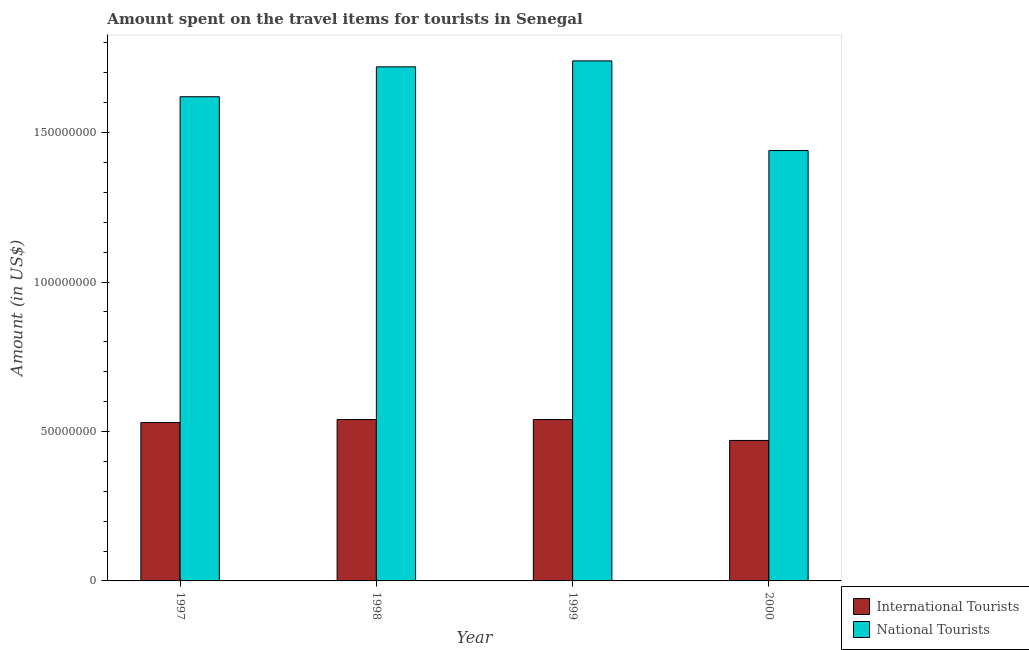How many different coloured bars are there?
Your response must be concise. 2. How many groups of bars are there?
Provide a succinct answer. 4. Are the number of bars per tick equal to the number of legend labels?
Give a very brief answer. Yes. How many bars are there on the 1st tick from the left?
Your answer should be very brief. 2. What is the label of the 4th group of bars from the left?
Your answer should be compact. 2000. What is the amount spent on travel items of national tourists in 1997?
Your response must be concise. 1.62e+08. Across all years, what is the maximum amount spent on travel items of international tourists?
Your response must be concise. 5.40e+07. Across all years, what is the minimum amount spent on travel items of international tourists?
Offer a very short reply. 4.70e+07. What is the total amount spent on travel items of national tourists in the graph?
Keep it short and to the point. 6.52e+08. What is the difference between the amount spent on travel items of international tourists in 1997 and that in 1998?
Ensure brevity in your answer.  -1.00e+06. What is the difference between the amount spent on travel items of national tourists in 2000 and the amount spent on travel items of international tourists in 1997?
Provide a short and direct response. -1.80e+07. What is the average amount spent on travel items of international tourists per year?
Ensure brevity in your answer.  5.20e+07. In the year 1999, what is the difference between the amount spent on travel items of international tourists and amount spent on travel items of national tourists?
Your response must be concise. 0. In how many years, is the amount spent on travel items of national tourists greater than 140000000 US$?
Your response must be concise. 4. What is the ratio of the amount spent on travel items of international tourists in 1997 to that in 1999?
Offer a terse response. 0.98. Is the amount spent on travel items of national tourists in 1998 less than that in 2000?
Ensure brevity in your answer.  No. Is the difference between the amount spent on travel items of international tourists in 1998 and 1999 greater than the difference between the amount spent on travel items of national tourists in 1998 and 1999?
Your answer should be compact. No. What is the difference between the highest and the second highest amount spent on travel items of national tourists?
Give a very brief answer. 2.00e+06. What is the difference between the highest and the lowest amount spent on travel items of national tourists?
Your answer should be very brief. 3.00e+07. In how many years, is the amount spent on travel items of national tourists greater than the average amount spent on travel items of national tourists taken over all years?
Provide a succinct answer. 2. What does the 2nd bar from the left in 1998 represents?
Your response must be concise. National Tourists. What does the 1st bar from the right in 1998 represents?
Your answer should be very brief. National Tourists. Are all the bars in the graph horizontal?
Give a very brief answer. No. Are the values on the major ticks of Y-axis written in scientific E-notation?
Provide a succinct answer. No. How many legend labels are there?
Make the answer very short. 2. How are the legend labels stacked?
Give a very brief answer. Vertical. What is the title of the graph?
Your answer should be very brief. Amount spent on the travel items for tourists in Senegal. What is the label or title of the Y-axis?
Provide a short and direct response. Amount (in US$). What is the Amount (in US$) of International Tourists in 1997?
Your answer should be very brief. 5.30e+07. What is the Amount (in US$) of National Tourists in 1997?
Provide a succinct answer. 1.62e+08. What is the Amount (in US$) of International Tourists in 1998?
Give a very brief answer. 5.40e+07. What is the Amount (in US$) in National Tourists in 1998?
Offer a terse response. 1.72e+08. What is the Amount (in US$) in International Tourists in 1999?
Your answer should be compact. 5.40e+07. What is the Amount (in US$) in National Tourists in 1999?
Your response must be concise. 1.74e+08. What is the Amount (in US$) in International Tourists in 2000?
Offer a terse response. 4.70e+07. What is the Amount (in US$) of National Tourists in 2000?
Give a very brief answer. 1.44e+08. Across all years, what is the maximum Amount (in US$) of International Tourists?
Ensure brevity in your answer.  5.40e+07. Across all years, what is the maximum Amount (in US$) in National Tourists?
Ensure brevity in your answer.  1.74e+08. Across all years, what is the minimum Amount (in US$) in International Tourists?
Provide a short and direct response. 4.70e+07. Across all years, what is the minimum Amount (in US$) in National Tourists?
Provide a short and direct response. 1.44e+08. What is the total Amount (in US$) of International Tourists in the graph?
Keep it short and to the point. 2.08e+08. What is the total Amount (in US$) in National Tourists in the graph?
Ensure brevity in your answer.  6.52e+08. What is the difference between the Amount (in US$) of International Tourists in 1997 and that in 1998?
Your answer should be compact. -1.00e+06. What is the difference between the Amount (in US$) of National Tourists in 1997 and that in 1998?
Ensure brevity in your answer.  -1.00e+07. What is the difference between the Amount (in US$) in International Tourists in 1997 and that in 1999?
Keep it short and to the point. -1.00e+06. What is the difference between the Amount (in US$) of National Tourists in 1997 and that in 1999?
Offer a very short reply. -1.20e+07. What is the difference between the Amount (in US$) in National Tourists in 1997 and that in 2000?
Keep it short and to the point. 1.80e+07. What is the difference between the Amount (in US$) of National Tourists in 1998 and that in 2000?
Keep it short and to the point. 2.80e+07. What is the difference between the Amount (in US$) of National Tourists in 1999 and that in 2000?
Your answer should be very brief. 3.00e+07. What is the difference between the Amount (in US$) in International Tourists in 1997 and the Amount (in US$) in National Tourists in 1998?
Give a very brief answer. -1.19e+08. What is the difference between the Amount (in US$) of International Tourists in 1997 and the Amount (in US$) of National Tourists in 1999?
Keep it short and to the point. -1.21e+08. What is the difference between the Amount (in US$) of International Tourists in 1997 and the Amount (in US$) of National Tourists in 2000?
Give a very brief answer. -9.10e+07. What is the difference between the Amount (in US$) in International Tourists in 1998 and the Amount (in US$) in National Tourists in 1999?
Ensure brevity in your answer.  -1.20e+08. What is the difference between the Amount (in US$) of International Tourists in 1998 and the Amount (in US$) of National Tourists in 2000?
Give a very brief answer. -9.00e+07. What is the difference between the Amount (in US$) in International Tourists in 1999 and the Amount (in US$) in National Tourists in 2000?
Provide a short and direct response. -9.00e+07. What is the average Amount (in US$) of International Tourists per year?
Offer a very short reply. 5.20e+07. What is the average Amount (in US$) of National Tourists per year?
Provide a short and direct response. 1.63e+08. In the year 1997, what is the difference between the Amount (in US$) of International Tourists and Amount (in US$) of National Tourists?
Your response must be concise. -1.09e+08. In the year 1998, what is the difference between the Amount (in US$) of International Tourists and Amount (in US$) of National Tourists?
Offer a very short reply. -1.18e+08. In the year 1999, what is the difference between the Amount (in US$) of International Tourists and Amount (in US$) of National Tourists?
Your response must be concise. -1.20e+08. In the year 2000, what is the difference between the Amount (in US$) in International Tourists and Amount (in US$) in National Tourists?
Ensure brevity in your answer.  -9.70e+07. What is the ratio of the Amount (in US$) in International Tourists in 1997 to that in 1998?
Your response must be concise. 0.98. What is the ratio of the Amount (in US$) in National Tourists in 1997 to that in 1998?
Give a very brief answer. 0.94. What is the ratio of the Amount (in US$) in International Tourists in 1997 to that in 1999?
Keep it short and to the point. 0.98. What is the ratio of the Amount (in US$) in National Tourists in 1997 to that in 1999?
Your answer should be very brief. 0.93. What is the ratio of the Amount (in US$) in International Tourists in 1997 to that in 2000?
Make the answer very short. 1.13. What is the ratio of the Amount (in US$) in International Tourists in 1998 to that in 1999?
Keep it short and to the point. 1. What is the ratio of the Amount (in US$) of International Tourists in 1998 to that in 2000?
Offer a very short reply. 1.15. What is the ratio of the Amount (in US$) of National Tourists in 1998 to that in 2000?
Keep it short and to the point. 1.19. What is the ratio of the Amount (in US$) in International Tourists in 1999 to that in 2000?
Provide a succinct answer. 1.15. What is the ratio of the Amount (in US$) in National Tourists in 1999 to that in 2000?
Your answer should be compact. 1.21. What is the difference between the highest and the second highest Amount (in US$) of International Tourists?
Ensure brevity in your answer.  0. What is the difference between the highest and the second highest Amount (in US$) of National Tourists?
Provide a succinct answer. 2.00e+06. What is the difference between the highest and the lowest Amount (in US$) of International Tourists?
Give a very brief answer. 7.00e+06. What is the difference between the highest and the lowest Amount (in US$) in National Tourists?
Keep it short and to the point. 3.00e+07. 